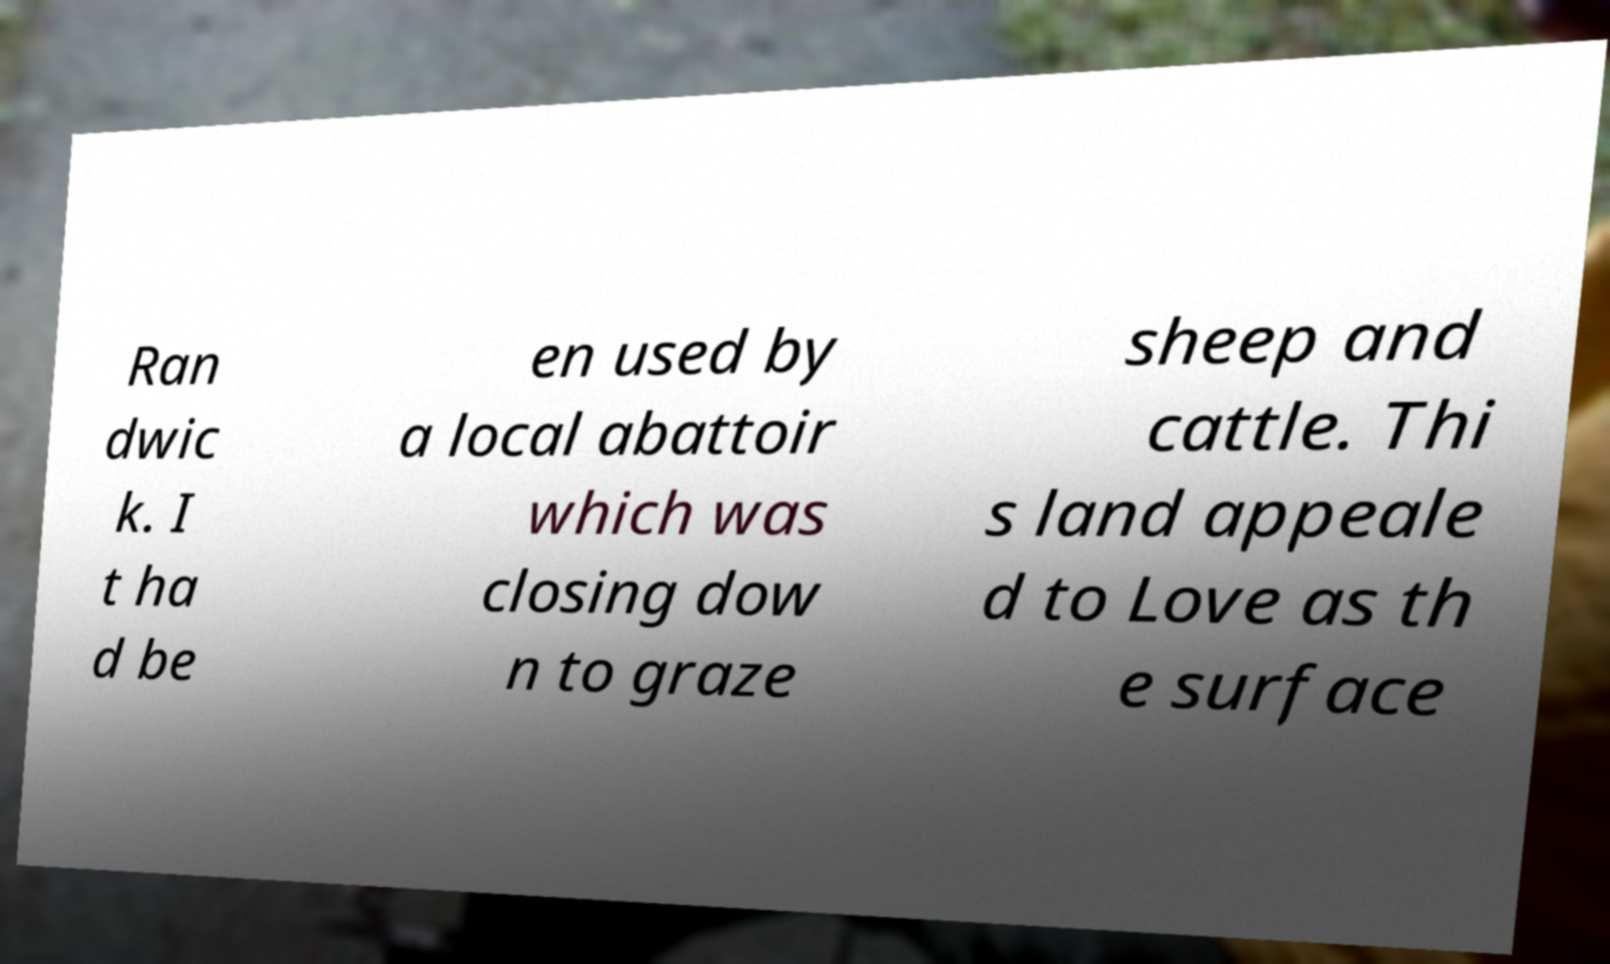Can you read and provide the text displayed in the image?This photo seems to have some interesting text. Can you extract and type it out for me? Ran dwic k. I t ha d be en used by a local abattoir which was closing dow n to graze sheep and cattle. Thi s land appeale d to Love as th e surface 